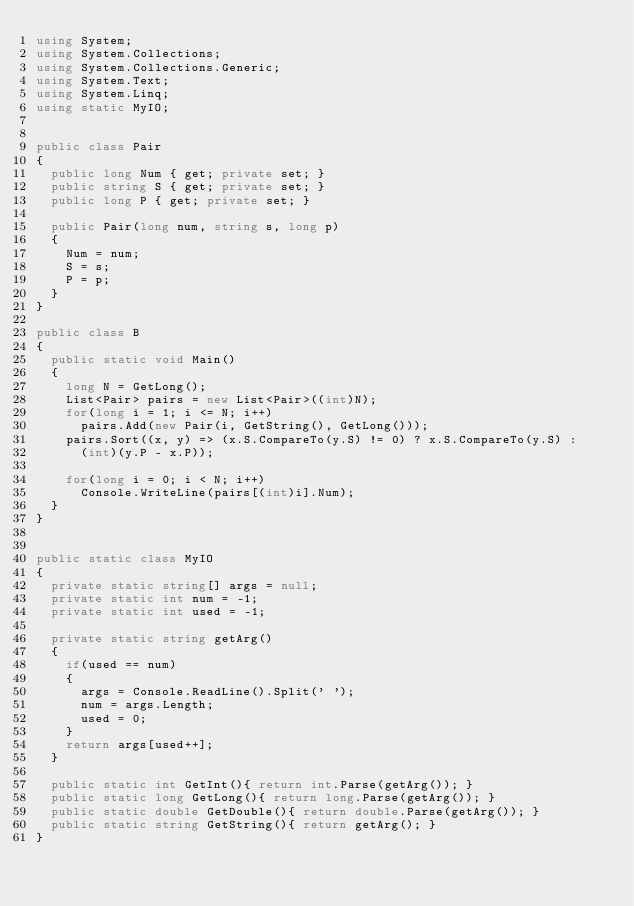Convert code to text. <code><loc_0><loc_0><loc_500><loc_500><_C#_>using System;
using System.Collections;
using System.Collections.Generic;
using System.Text;
using System.Linq;
using static MyIO;


public class Pair
{
	public long Num { get; private set; }
	public string S { get; private set; }
	public long P { get; private set; }

	public Pair(long num, string s, long p)
	{
		Num = num;
		S = s;
		P = p;
	}
}

public class B
{
	public static void Main()
	{
		long N = GetLong();
		List<Pair> pairs = new List<Pair>((int)N);
		for(long i = 1; i <= N; i++)
			pairs.Add(new Pair(i, GetString(), GetLong()));
		pairs.Sort((x, y) => (x.S.CompareTo(y.S) != 0) ? x.S.CompareTo(y.S) :
			(int)(y.P - x.P));

		for(long i = 0; i < N; i++)
			Console.WriteLine(pairs[(int)i].Num);
	}
}


public static class MyIO
{
	private static string[] args = null;
	private static int num = -1;
	private static int used = -1;

	private static string getArg()
	{
		if(used == num)
		{
			args = Console.ReadLine().Split(' ');
			num = args.Length;
			used = 0;
		}
		return args[used++];
	}

	public static int GetInt(){ return int.Parse(getArg()); }
	public static long GetLong(){ return long.Parse(getArg()); }
	public static double GetDouble(){ return double.Parse(getArg()); }
	public static string GetString(){ return getArg(); }
}
</code> 